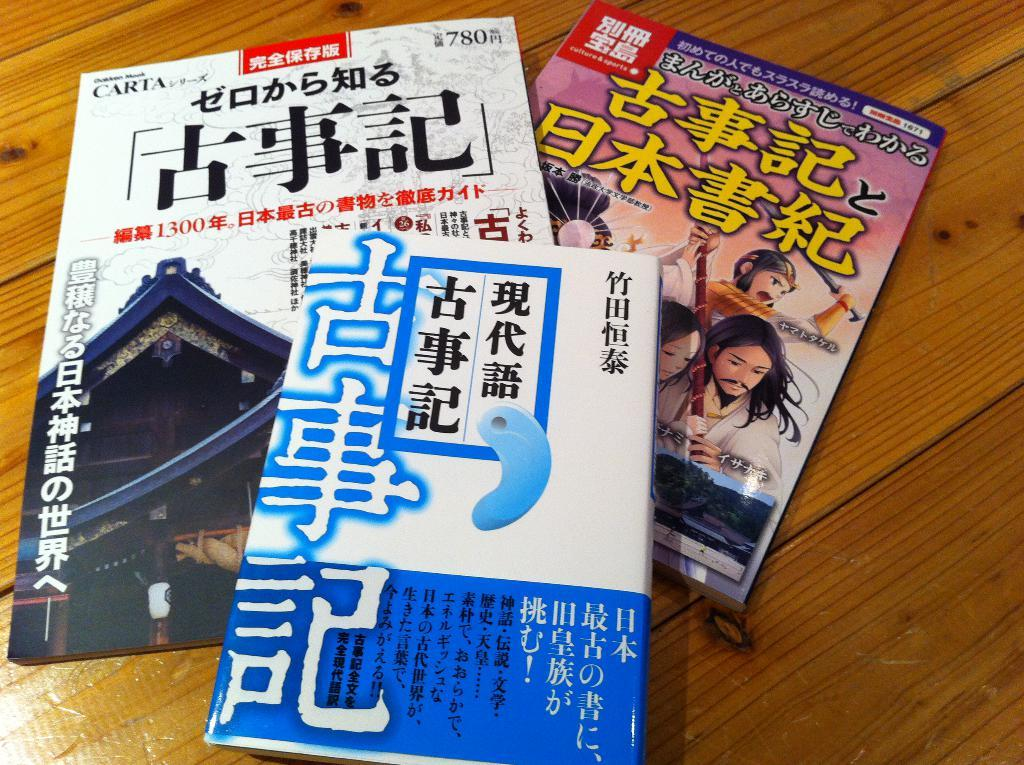<image>
Give a short and clear explanation of the subsequent image. A group of 3 booklets with Asian writing on the front. 